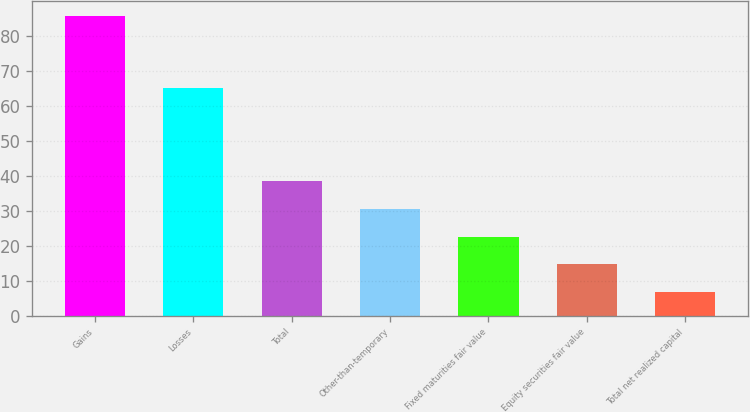<chart> <loc_0><loc_0><loc_500><loc_500><bar_chart><fcel>Gains<fcel>Losses<fcel>Total<fcel>Other-than-temporary<fcel>Fixed maturities fair value<fcel>Equity securities fair value<fcel>Total net realized capital<nl><fcel>85.5<fcel>65.1<fcel>38.34<fcel>30.48<fcel>22.62<fcel>14.76<fcel>6.9<nl></chart> 